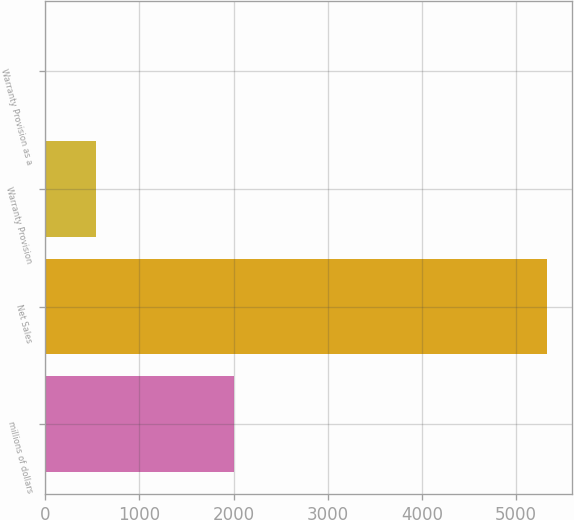<chart> <loc_0><loc_0><loc_500><loc_500><bar_chart><fcel>millions of dollars<fcel>Net Sales<fcel>Warranty Provision<fcel>Warranty Provision as a<nl><fcel>2007<fcel>5328.6<fcel>533.85<fcel>1.1<nl></chart> 